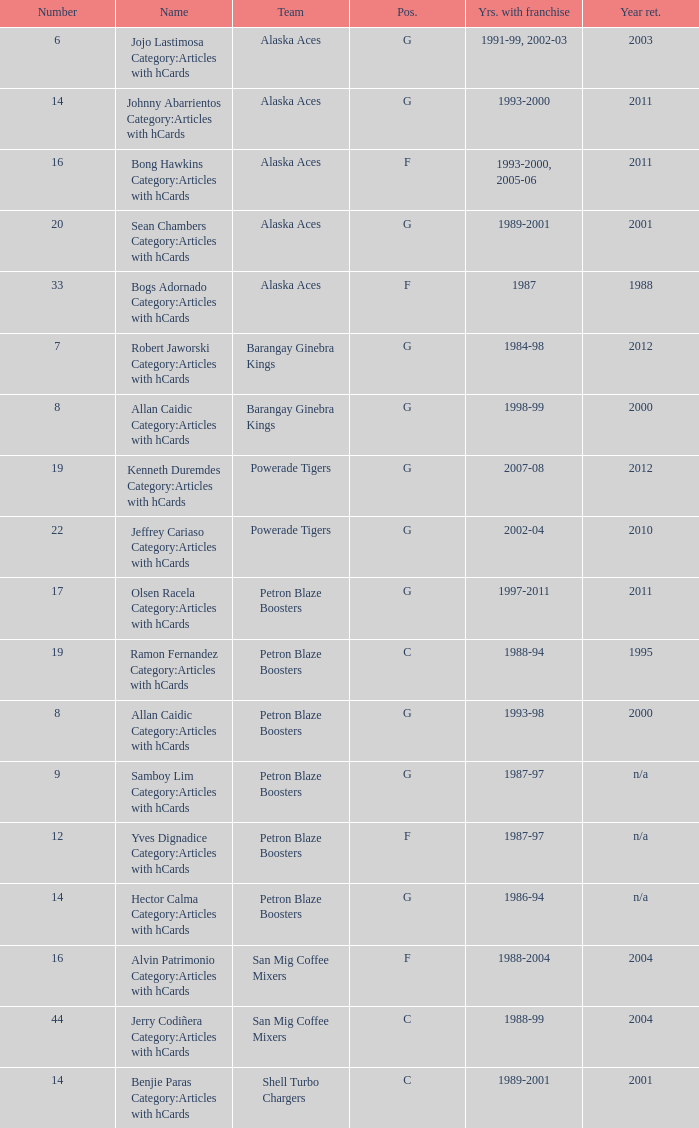How many years did the team in slot number 9 have a franchise? 1987-97. 